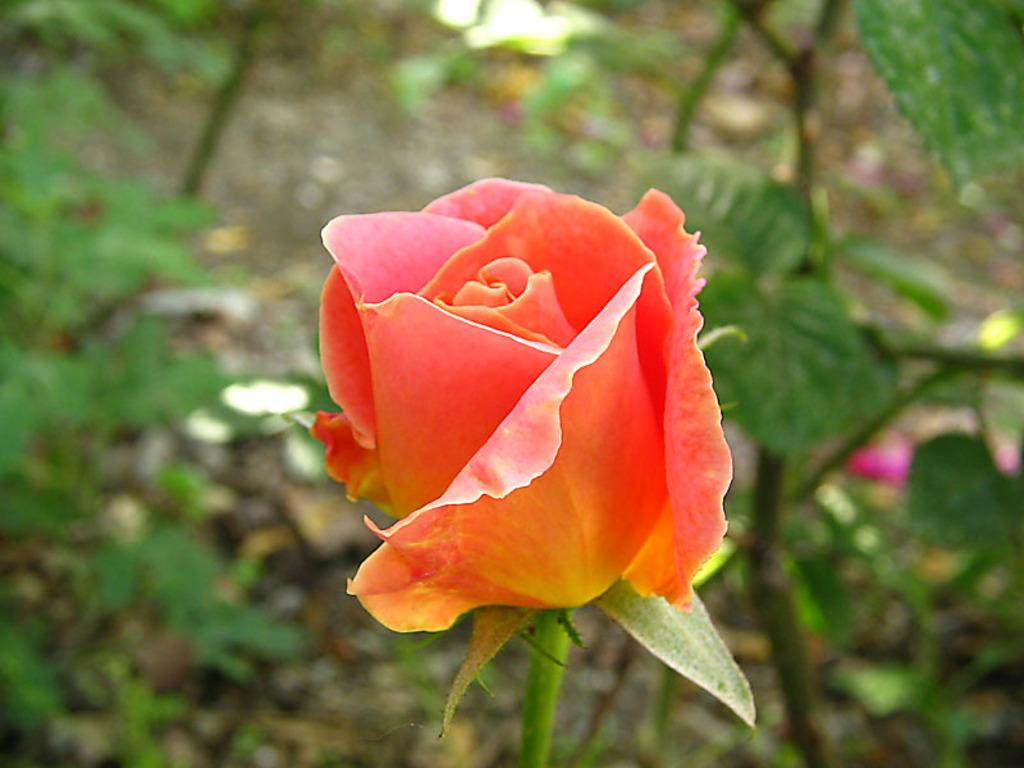What is the main subject of the image? There is a flower in the middle of the image. What can be seen in the background of the image? There are trees in the background of the image. How is the background of the image depicted? The background of the image is blurred. How many hooks are attached to the flower in the image? There are no hooks present in the image; it features a flower with no visible attachments. Is there a crown visible on the flower in the image? There is no crown present in the image; it features a flower without any adornments. 